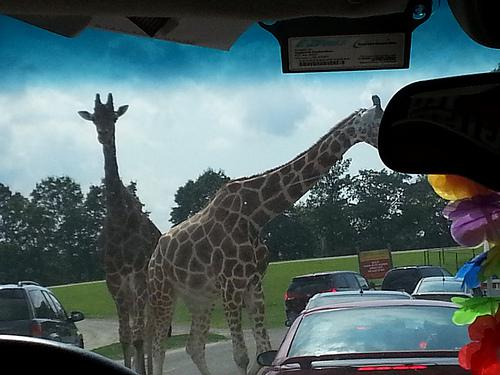Question: why are the Giraffes standing in the middle of traffic?
Choices:
A. Drive-thru Zoo.
B. They are lost.
C. There is food.
D. They are crossing the street.
Answer with the letter. Answer: A Question: what type of facility is this?
Choices:
A. Controlled captivity.
B. Jail.
C. Retirement home.
D. Hospital.
Answer with the letter. Answer: A Question: when is this photo taken?
Choices:
A. At night.
B. In the morning.
C. In the summer.
D. During the day.
Answer with the letter. Answer: D 